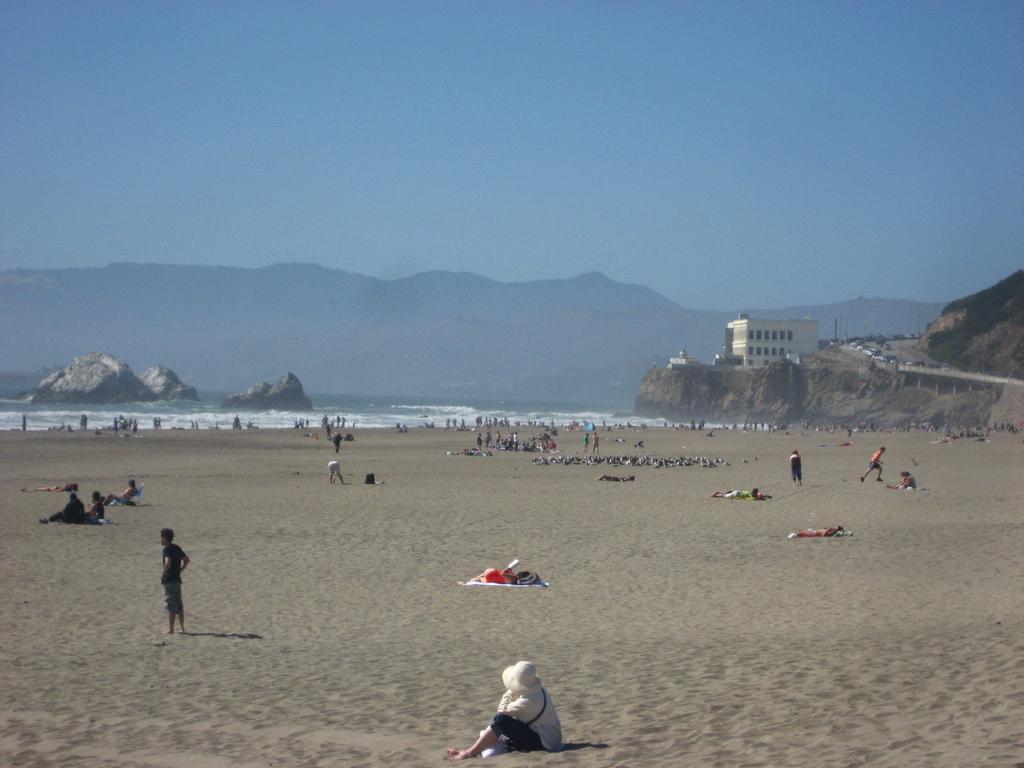Describe this image in one or two sentences. In the foreground we can see a person sitting on the sand and here we can see the cap on his head. In the background, we can see a few people on the side of a beach. In the background, we can see the ocean. Here we can see the rocks. Here we can see the building on the right side. Here we can see the vehicles on the road and they are on the right side. In the background, we can see the mountains. This is a blue sky. 